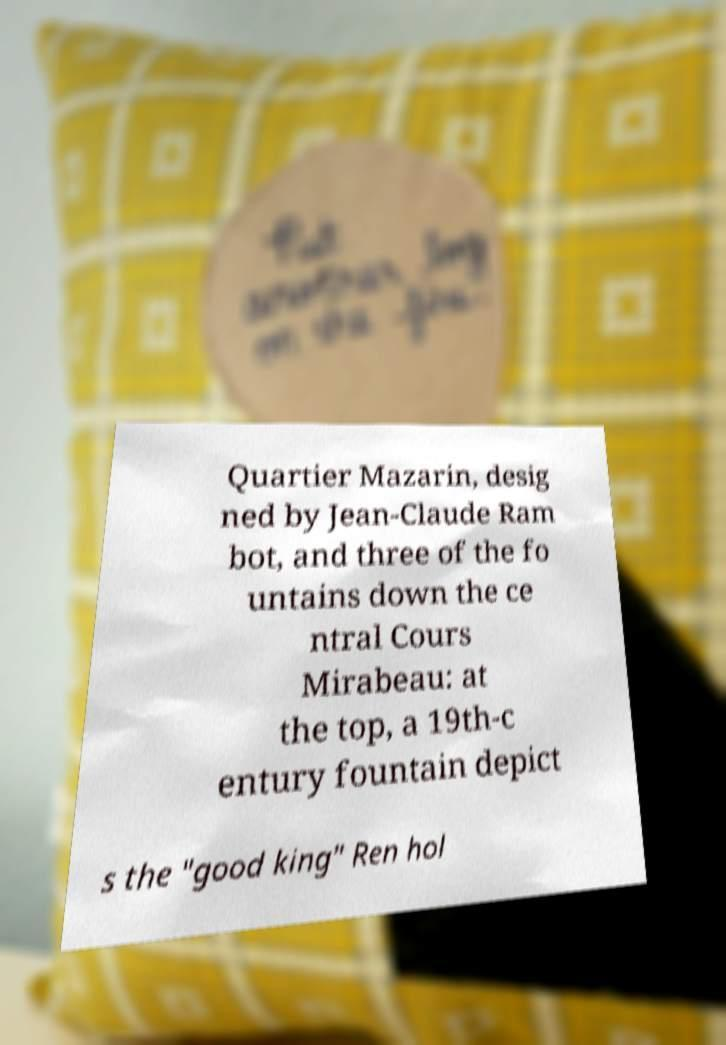Please read and relay the text visible in this image. What does it say? Quartier Mazarin, desig ned by Jean-Claude Ram bot, and three of the fo untains down the ce ntral Cours Mirabeau: at the top, a 19th-c entury fountain depict s the "good king" Ren hol 